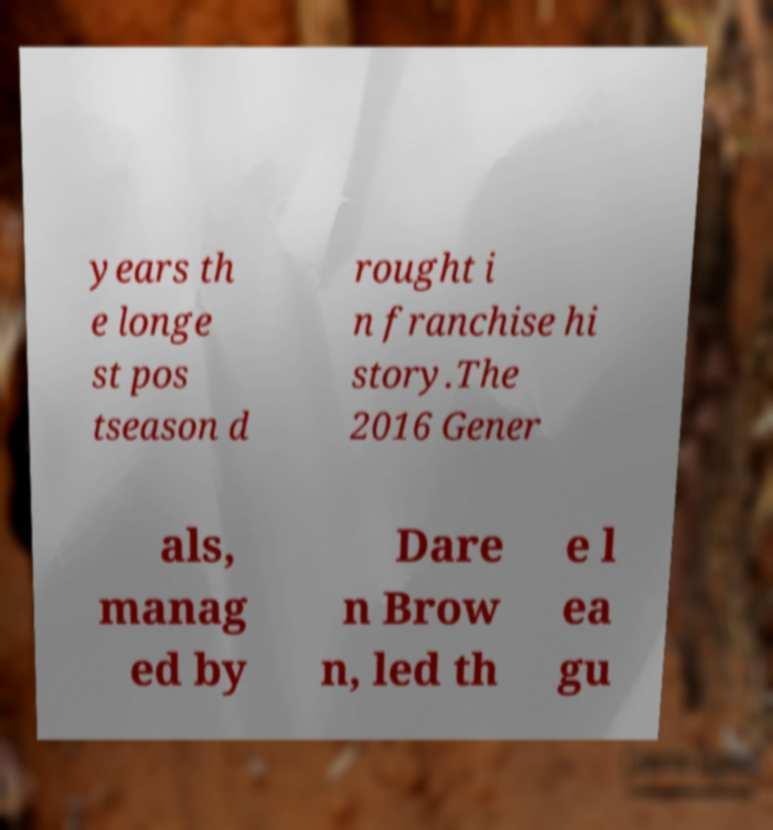For documentation purposes, I need the text within this image transcribed. Could you provide that? years th e longe st pos tseason d rought i n franchise hi story.The 2016 Gener als, manag ed by Dare n Brow n, led th e l ea gu 